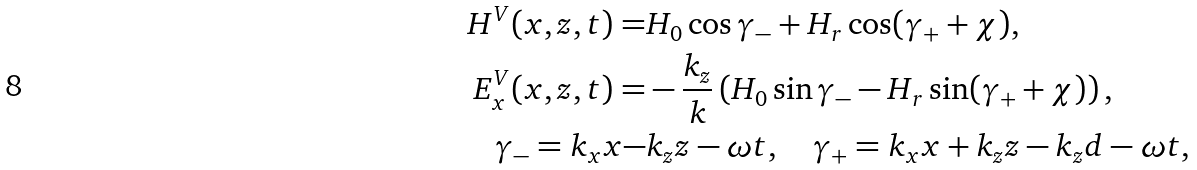<formula> <loc_0><loc_0><loc_500><loc_500>H ^ { V } ( x , z , t ) = & H _ { 0 } \cos \gamma _ { - } + H _ { r } \cos ( \gamma _ { + } + \chi ) , \\ E _ { x } ^ { V } ( x , z , t ) = & - \frac { k _ { z } } { k } \left ( H _ { 0 } \sin \gamma _ { - } - H _ { r } \sin ( \gamma _ { + } + \chi ) \right ) , \\ \gamma _ { - } = k _ { x } x - & k _ { z } z - \omega t , \quad \gamma _ { + } = k _ { x } x + k _ { z } z - k _ { z } d - \omega t ,</formula> 